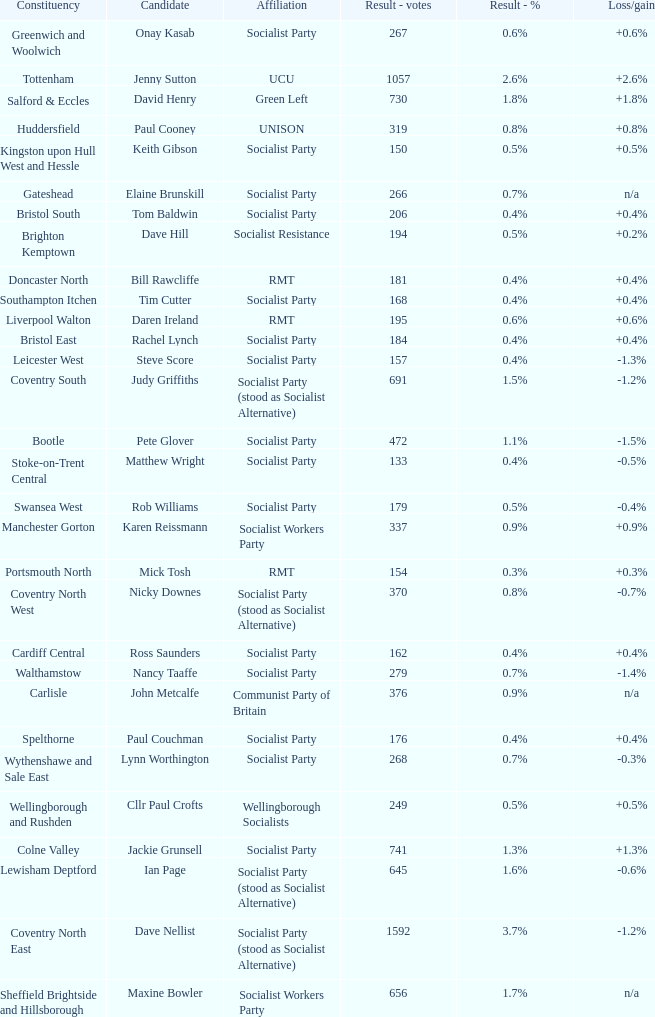What is every affiliation for the Tottenham constituency? UCU. 